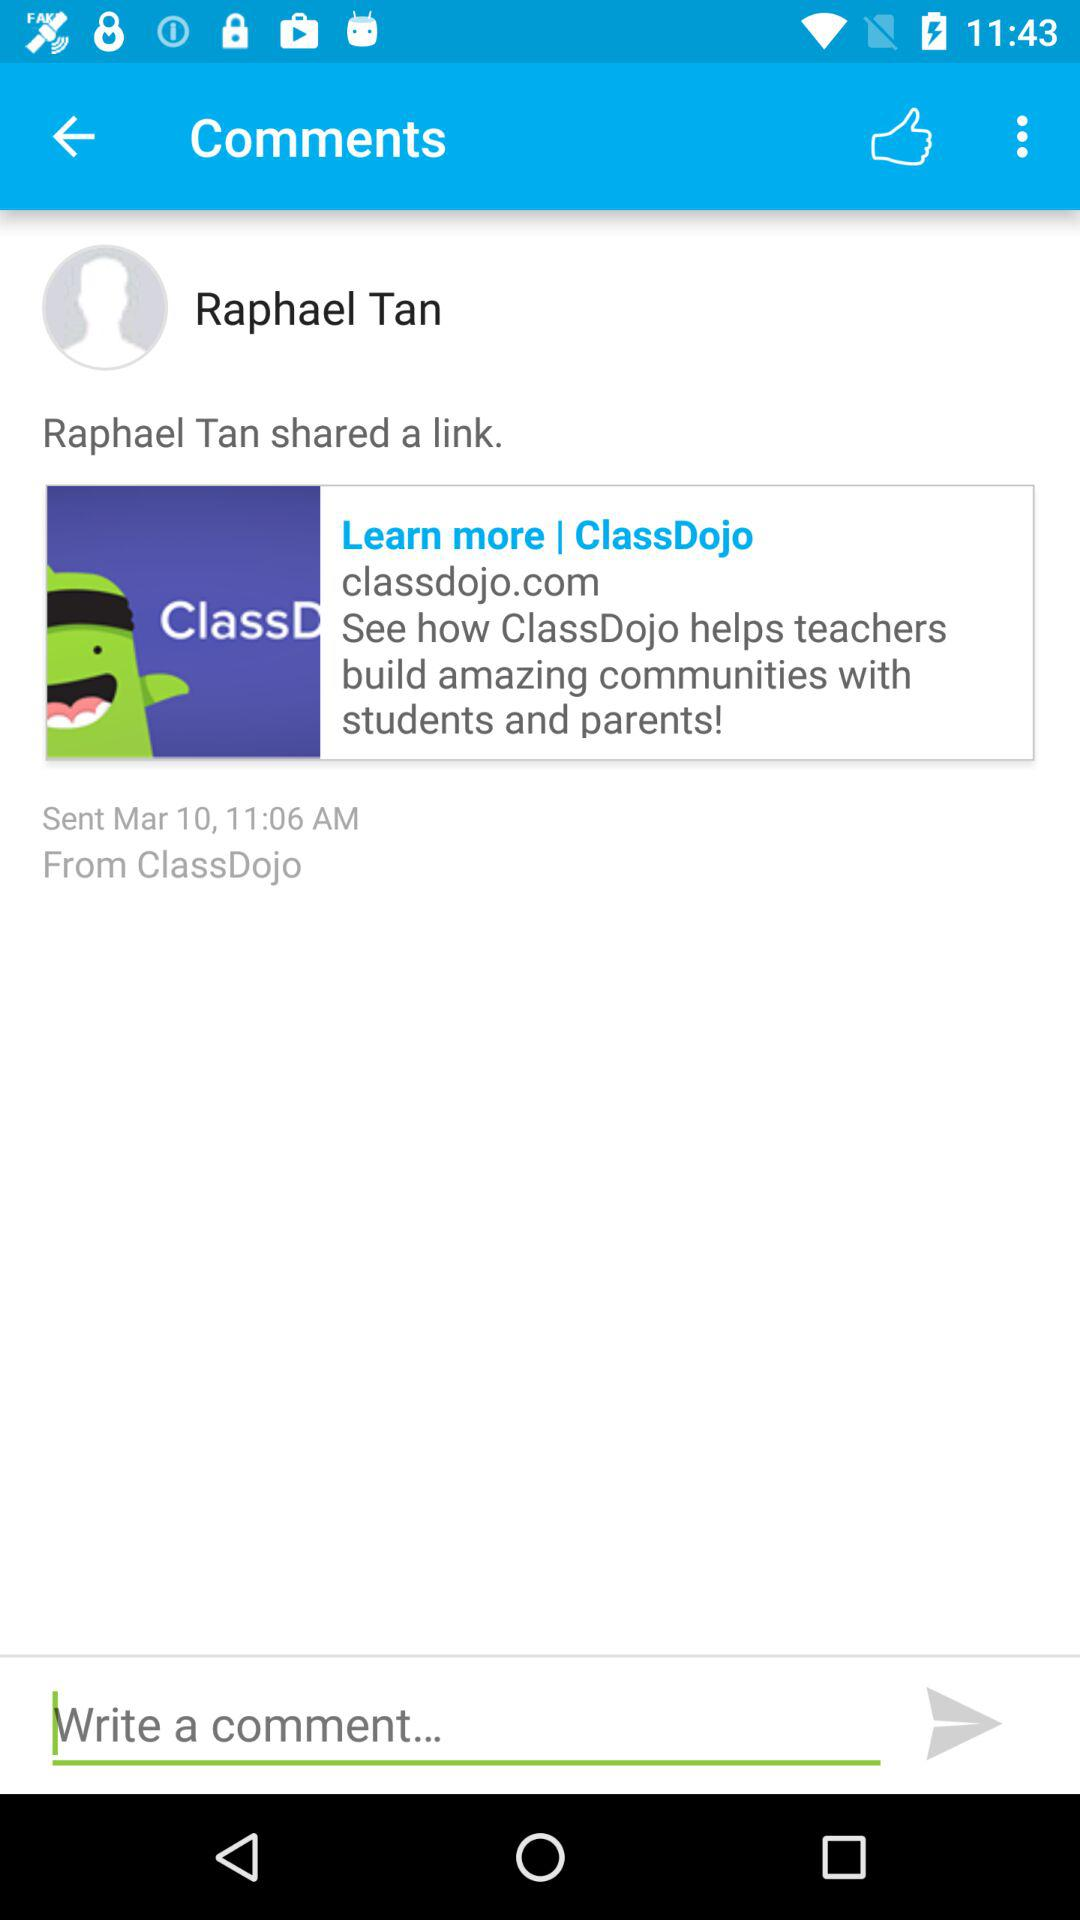What is the name of the user? The name of the user is Raphael Tan. 